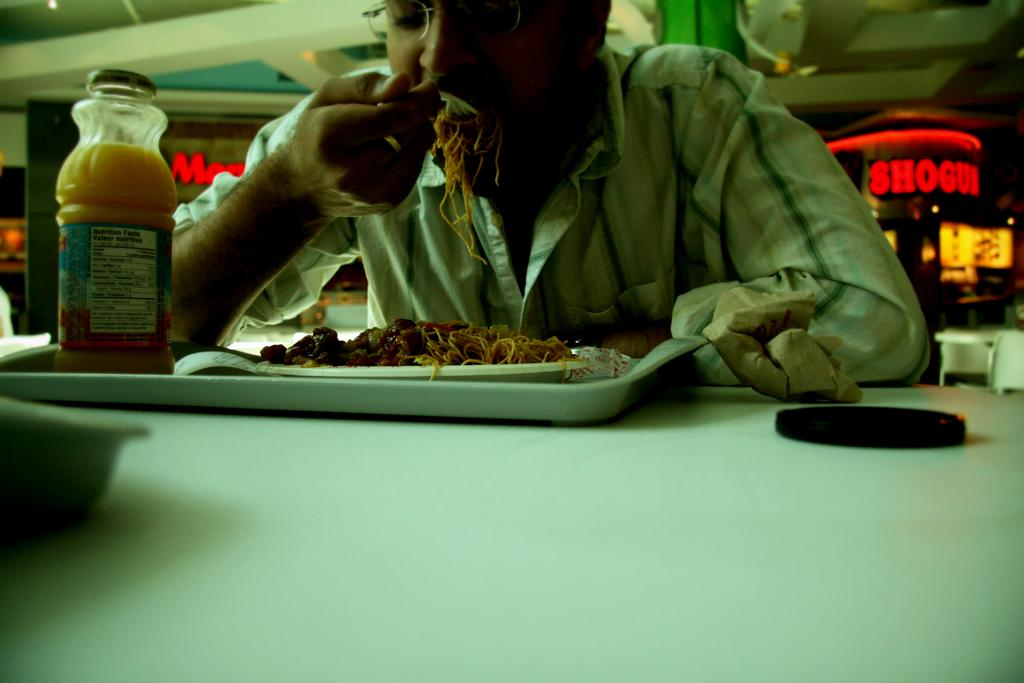What is the man in the image doing? The man is taking food in the image. Can you describe the man's position in the image? The man is seated in the image. What is on the table in the image? There is a juice bottle on the table in the image. How many friends is the man with in the image? The provided facts do not mention any friends in the image, so we cannot determine the number of friends the man is with. What type of fish can be seen swimming in the image? There is no fish present in the image. 